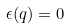Convert formula to latex. <formula><loc_0><loc_0><loc_500><loc_500>\epsilon ( q ) = 0</formula> 